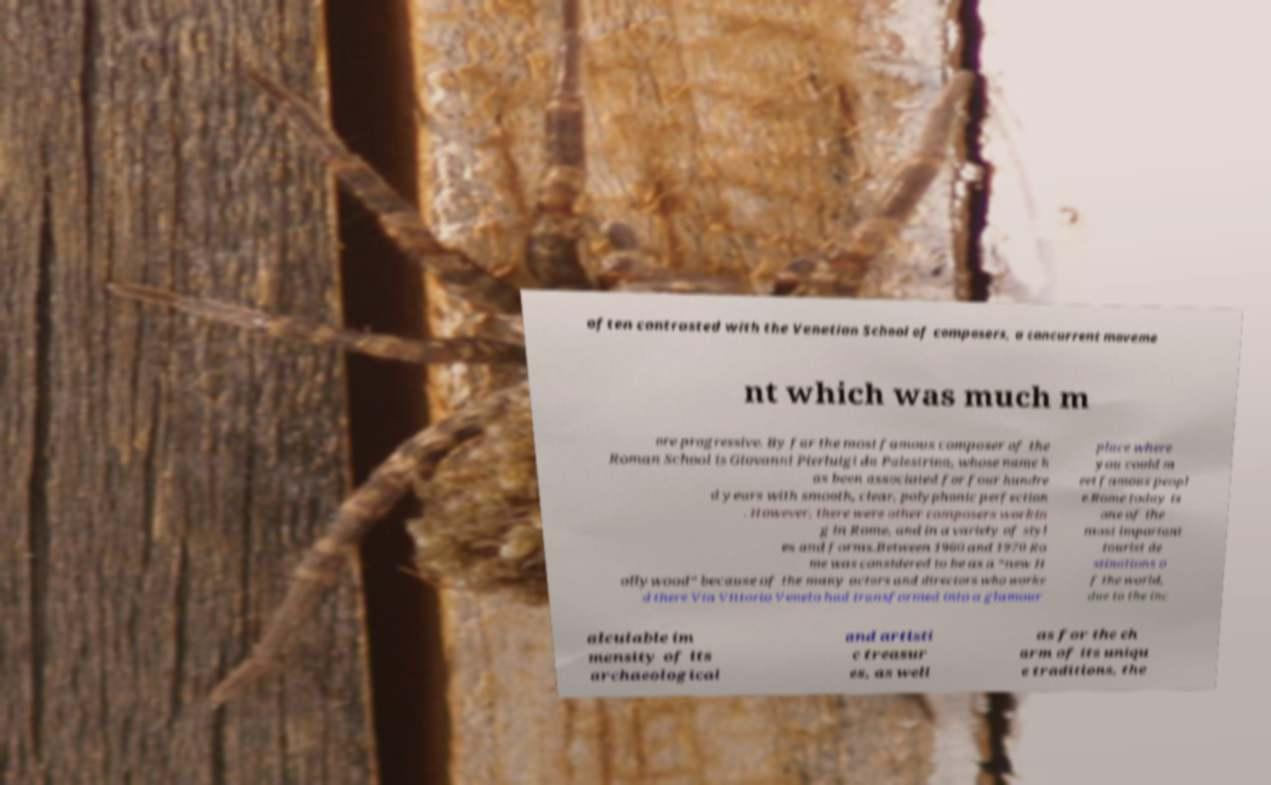There's text embedded in this image that I need extracted. Can you transcribe it verbatim? often contrasted with the Venetian School of composers, a concurrent moveme nt which was much m ore progressive. By far the most famous composer of the Roman School is Giovanni Pierluigi da Palestrina, whose name h as been associated for four hundre d years with smooth, clear, polyphonic perfection . However, there were other composers workin g in Rome, and in a variety of styl es and forms.Between 1960 and 1970 Ro me was considered to be as a “new H ollywood” because of the many actors and directors who worke d there Via Vittorio Veneto had transformed into a glamour place where you could m eet famous peopl e.Rome today is one of the most important tourist de stinations o f the world, due to the inc alculable im mensity of its archaeological and artisti c treasur es, as well as for the ch arm of its uniqu e traditions, the 